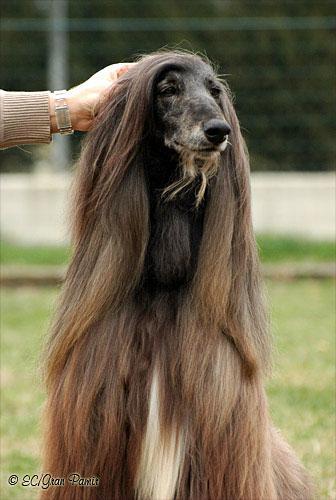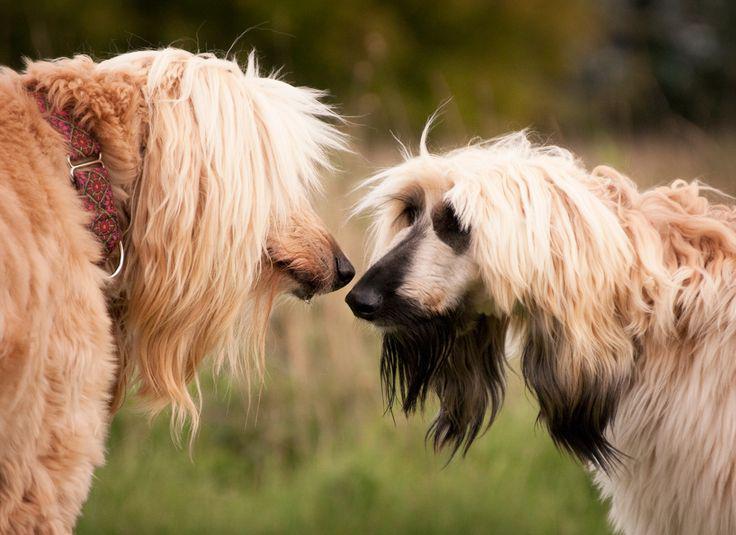The first image is the image on the left, the second image is the image on the right. Evaluate the accuracy of this statement regarding the images: "A human's arm can be seen in one of the photos.". Is it true? Answer yes or no. Yes. The first image is the image on the left, the second image is the image on the right. For the images displayed, is the sentence "There are two dogs facing each other in the image on the right." factually correct? Answer yes or no. Yes. 